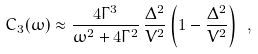Convert formula to latex. <formula><loc_0><loc_0><loc_500><loc_500>C _ { 3 } ( \omega ) \approx \frac { 4 \Gamma ^ { 3 } } { \omega ^ { 2 } + 4 \Gamma ^ { 2 } } \, \frac { \Delta ^ { 2 } } { V ^ { 2 } } \left ( 1 - \frac { \Delta ^ { 2 } } { V ^ { 2 } } \right ) \ ,</formula> 